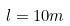Convert formula to latex. <formula><loc_0><loc_0><loc_500><loc_500>l = 1 0 m</formula> 